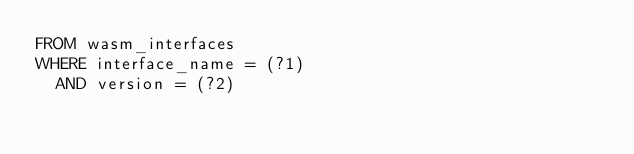<code> <loc_0><loc_0><loc_500><loc_500><_SQL_>FROM wasm_interfaces
WHERE interface_name = (?1)
  AND version = (?2)
</code> 